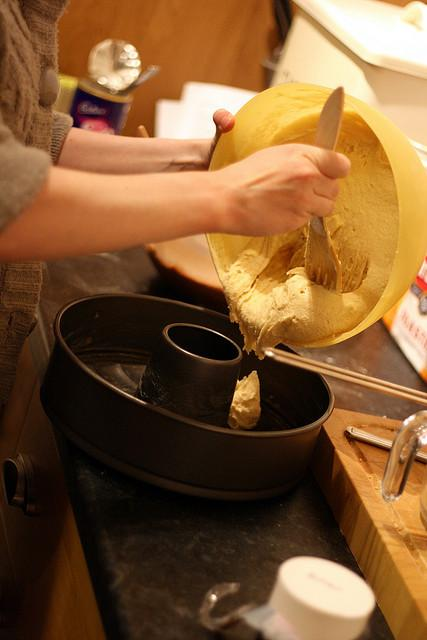What is being poured here?

Choices:
A) corn mush
B) grits
C) cake batter
D) milk cake batter 